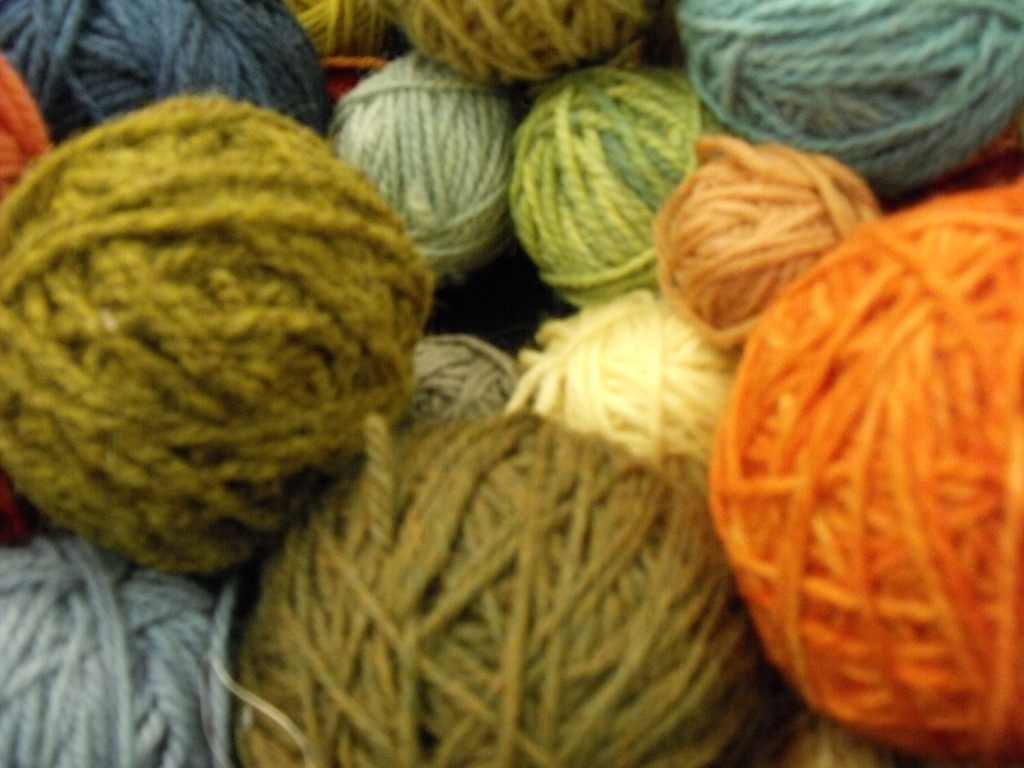How would you describe the color palette of this image? The color palette in the image is diverse and earthy, featuring shades of green, blue, orange, red, and white. It's a rich tapestry of hues that evoke a natural and cozy feel, indicating the types of projects these yarns could be used for, perhaps autumnal or wintertime knits. 